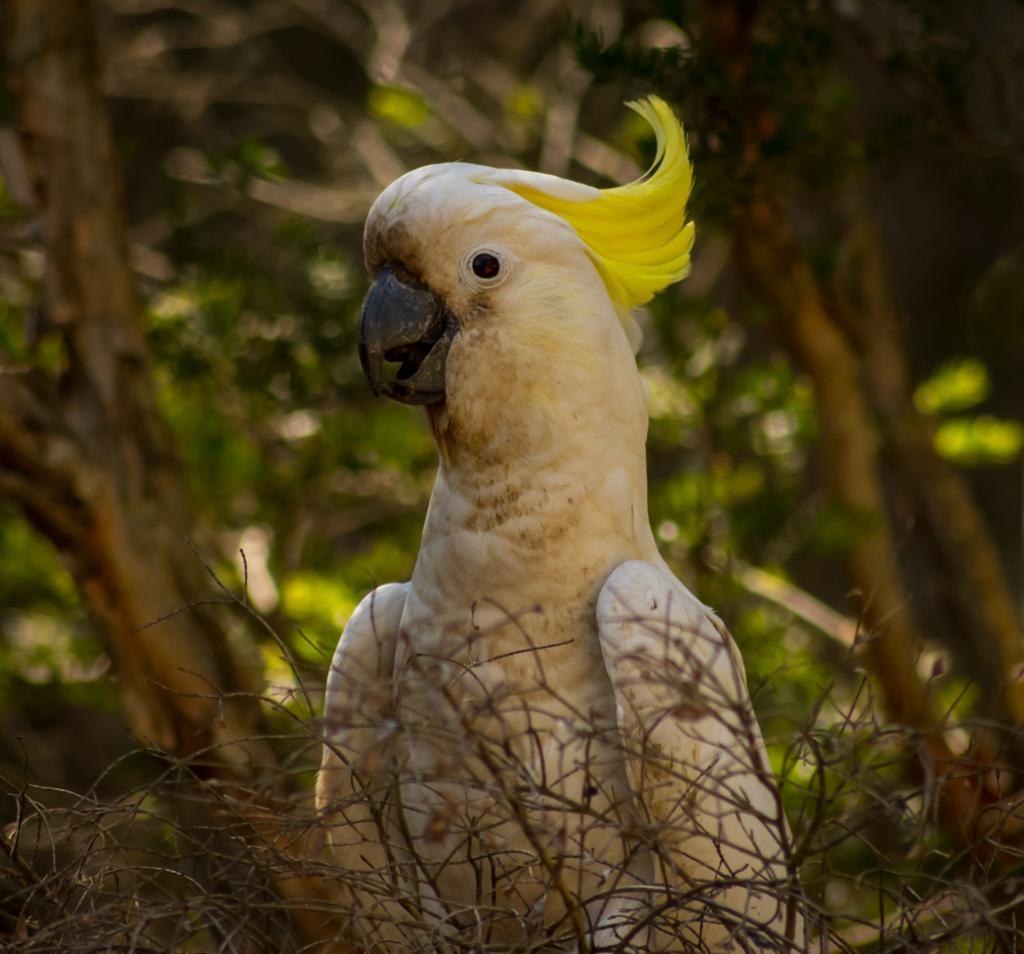How would you summarize this image in a sentence or two? In this image, we can see a bird. There are some dried plants. In the background, we can see some trees. 